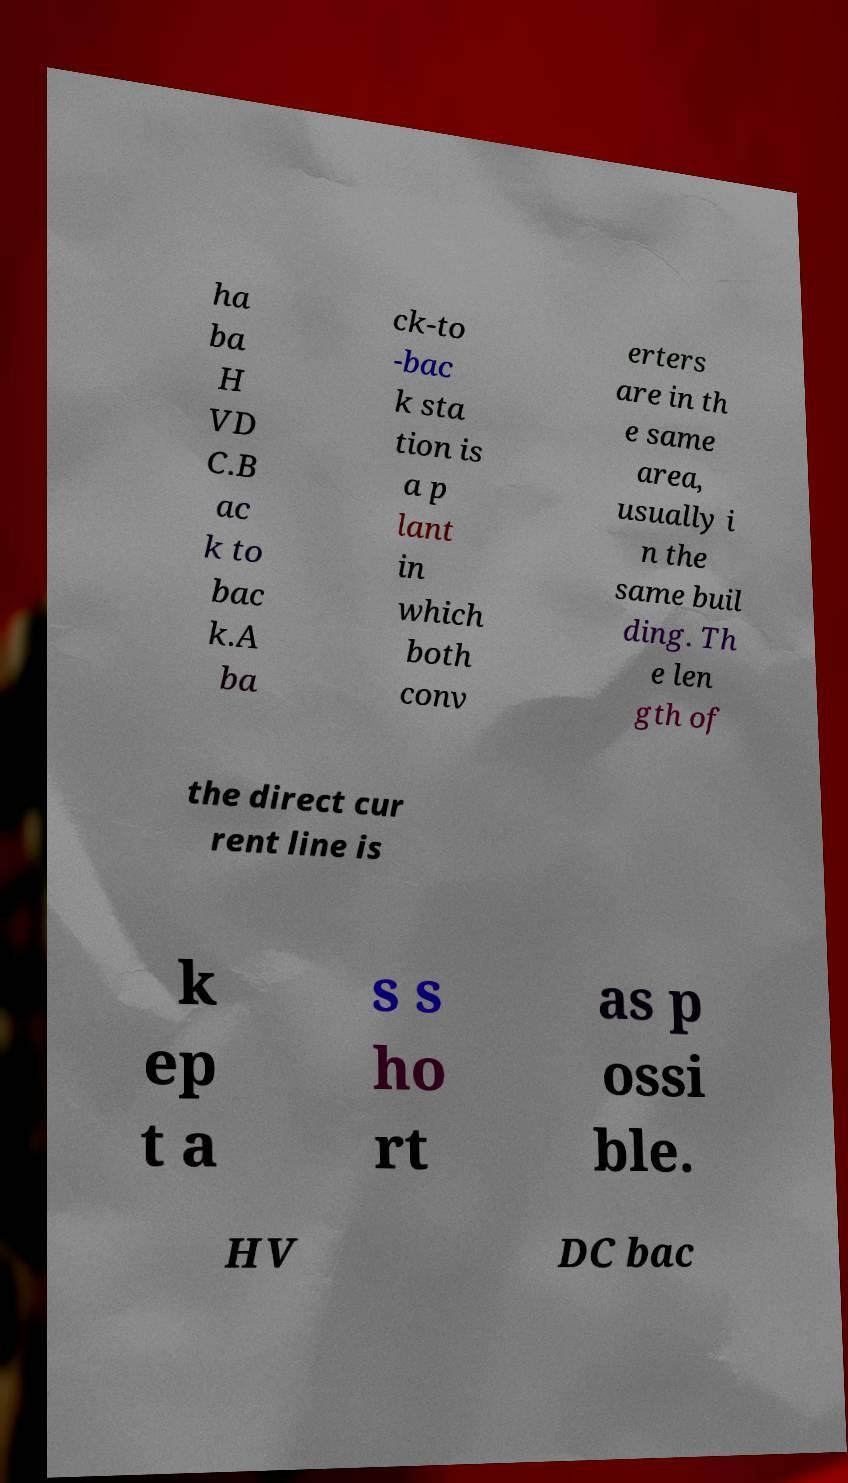What messages or text are displayed in this image? I need them in a readable, typed format. ha ba H VD C.B ac k to bac k.A ba ck-to -bac k sta tion is a p lant in which both conv erters are in th e same area, usually i n the same buil ding. Th e len gth of the direct cur rent line is k ep t a s s ho rt as p ossi ble. HV DC bac 